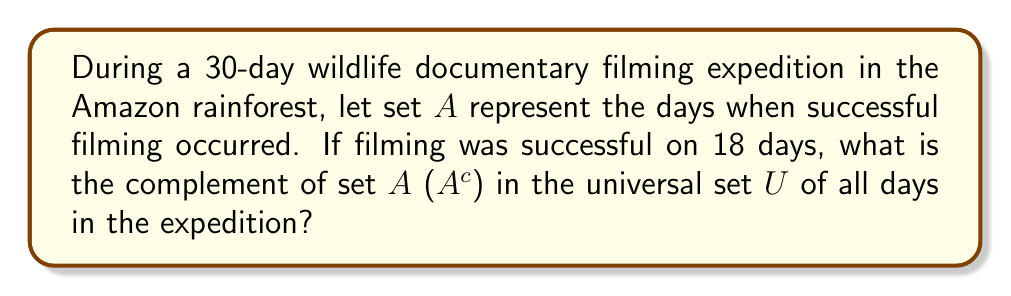Teach me how to tackle this problem. To solve this problem, we need to follow these steps:

1) First, let's define our universal set $U$:
   $U = \{1, 2, 3, ..., 30\}$ (all 30 days of the expedition)

2) We're told that set $A$ (successful filming days) contains 18 elements.

3) The complement of set $A$, denoted as $A^c$, is defined as all elements in the universal set $U$ that are not in $A$.

4) To find the number of elements in $A^c$, we can use the following formula:
   $n(A^c) = n(U) - n(A)$
   Where $n()$ represents the number of elements in a set.

5) We know that:
   $n(U) = 30$ (total days in the expedition)
   $n(A) = 18$ (successful filming days)

6) Let's substitute these values into our formula:
   $n(A^c) = 30 - 18 = 12$

7) Therefore, $A^c$ contains 12 elements, representing the days when successful filming did not occur.

8) While we don't know the specific days, we can represent $A^c$ as:
   $A^c = \{x \in U : x \notin A\}$
   Which reads as "the set of all elements $x$ in $U$ such that $x$ is not in $A$".
Answer: $A^c = \{x \in U : x \notin A\}$, where $|A^c| = 12$ 